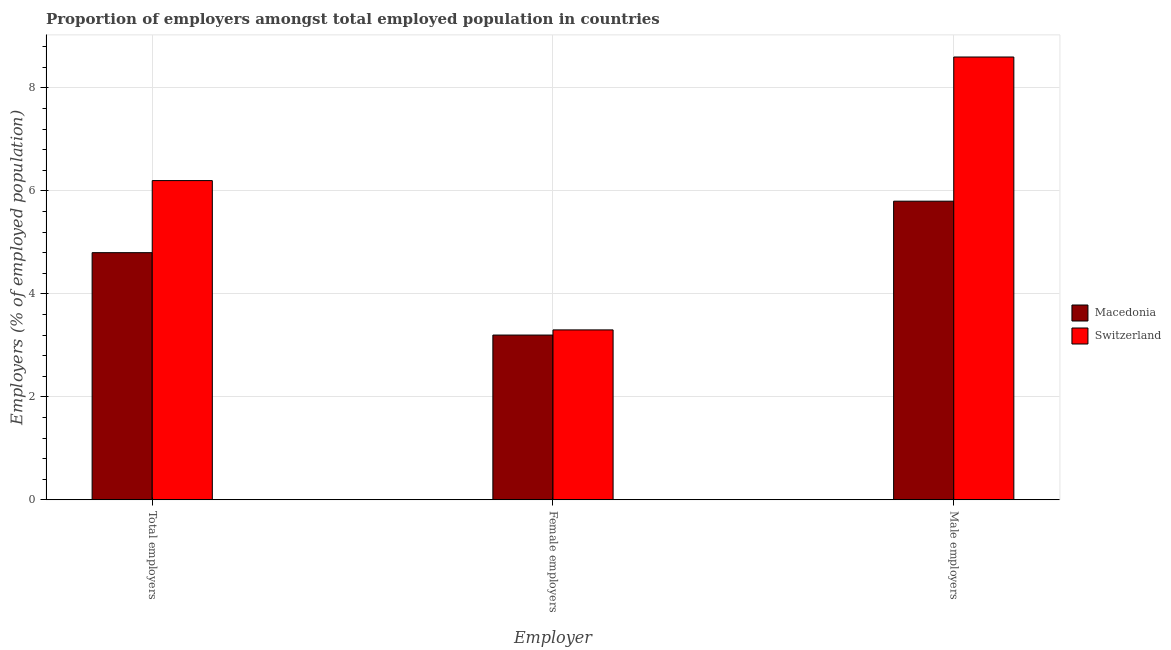Are the number of bars per tick equal to the number of legend labels?
Your response must be concise. Yes. How many bars are there on the 1st tick from the left?
Your answer should be compact. 2. What is the label of the 3rd group of bars from the left?
Make the answer very short. Male employers. What is the percentage of female employers in Macedonia?
Ensure brevity in your answer.  3.2. Across all countries, what is the maximum percentage of female employers?
Your answer should be compact. 3.3. Across all countries, what is the minimum percentage of total employers?
Offer a terse response. 4.8. In which country was the percentage of female employers maximum?
Make the answer very short. Switzerland. In which country was the percentage of female employers minimum?
Offer a very short reply. Macedonia. What is the total percentage of total employers in the graph?
Your answer should be compact. 11. What is the difference between the percentage of total employers in Switzerland and that in Macedonia?
Give a very brief answer. 1.4. What is the difference between the percentage of female employers in Macedonia and the percentage of total employers in Switzerland?
Your answer should be compact. -3. What is the difference between the percentage of total employers and percentage of male employers in Switzerland?
Your answer should be very brief. -2.4. What is the ratio of the percentage of female employers in Macedonia to that in Switzerland?
Offer a very short reply. 0.97. Is the difference between the percentage of total employers in Macedonia and Switzerland greater than the difference between the percentage of female employers in Macedonia and Switzerland?
Provide a short and direct response. No. What is the difference between the highest and the second highest percentage of total employers?
Offer a terse response. 1.4. What is the difference between the highest and the lowest percentage of total employers?
Give a very brief answer. 1.4. Is the sum of the percentage of total employers in Macedonia and Switzerland greater than the maximum percentage of male employers across all countries?
Your answer should be compact. Yes. What does the 2nd bar from the left in Male employers represents?
Offer a terse response. Switzerland. What does the 2nd bar from the right in Female employers represents?
Offer a very short reply. Macedonia. Are all the bars in the graph horizontal?
Provide a short and direct response. No. What is the difference between two consecutive major ticks on the Y-axis?
Provide a short and direct response. 2. Does the graph contain any zero values?
Your answer should be very brief. No. Where does the legend appear in the graph?
Offer a terse response. Center right. What is the title of the graph?
Give a very brief answer. Proportion of employers amongst total employed population in countries. Does "Lebanon" appear as one of the legend labels in the graph?
Offer a terse response. No. What is the label or title of the X-axis?
Offer a very short reply. Employer. What is the label or title of the Y-axis?
Provide a succinct answer. Employers (% of employed population). What is the Employers (% of employed population) of Macedonia in Total employers?
Make the answer very short. 4.8. What is the Employers (% of employed population) in Switzerland in Total employers?
Give a very brief answer. 6.2. What is the Employers (% of employed population) in Macedonia in Female employers?
Keep it short and to the point. 3.2. What is the Employers (% of employed population) of Switzerland in Female employers?
Ensure brevity in your answer.  3.3. What is the Employers (% of employed population) in Macedonia in Male employers?
Offer a very short reply. 5.8. What is the Employers (% of employed population) in Switzerland in Male employers?
Offer a terse response. 8.6. Across all Employer, what is the maximum Employers (% of employed population) of Macedonia?
Give a very brief answer. 5.8. Across all Employer, what is the maximum Employers (% of employed population) of Switzerland?
Your response must be concise. 8.6. Across all Employer, what is the minimum Employers (% of employed population) of Macedonia?
Make the answer very short. 3.2. Across all Employer, what is the minimum Employers (% of employed population) of Switzerland?
Offer a terse response. 3.3. What is the total Employers (% of employed population) of Switzerland in the graph?
Make the answer very short. 18.1. What is the difference between the Employers (% of employed population) in Switzerland in Total employers and that in Female employers?
Offer a terse response. 2.9. What is the difference between the Employers (% of employed population) of Macedonia in Female employers and that in Male employers?
Your answer should be very brief. -2.6. What is the difference between the Employers (% of employed population) of Macedonia in Female employers and the Employers (% of employed population) of Switzerland in Male employers?
Make the answer very short. -5.4. What is the average Employers (% of employed population) of Switzerland per Employer?
Provide a short and direct response. 6.03. What is the difference between the Employers (% of employed population) in Macedonia and Employers (% of employed population) in Switzerland in Male employers?
Keep it short and to the point. -2.8. What is the ratio of the Employers (% of employed population) in Macedonia in Total employers to that in Female employers?
Provide a succinct answer. 1.5. What is the ratio of the Employers (% of employed population) in Switzerland in Total employers to that in Female employers?
Your response must be concise. 1.88. What is the ratio of the Employers (% of employed population) in Macedonia in Total employers to that in Male employers?
Offer a very short reply. 0.83. What is the ratio of the Employers (% of employed population) of Switzerland in Total employers to that in Male employers?
Ensure brevity in your answer.  0.72. What is the ratio of the Employers (% of employed population) of Macedonia in Female employers to that in Male employers?
Provide a succinct answer. 0.55. What is the ratio of the Employers (% of employed population) of Switzerland in Female employers to that in Male employers?
Your answer should be very brief. 0.38. What is the difference between the highest and the second highest Employers (% of employed population) in Switzerland?
Make the answer very short. 2.4. 